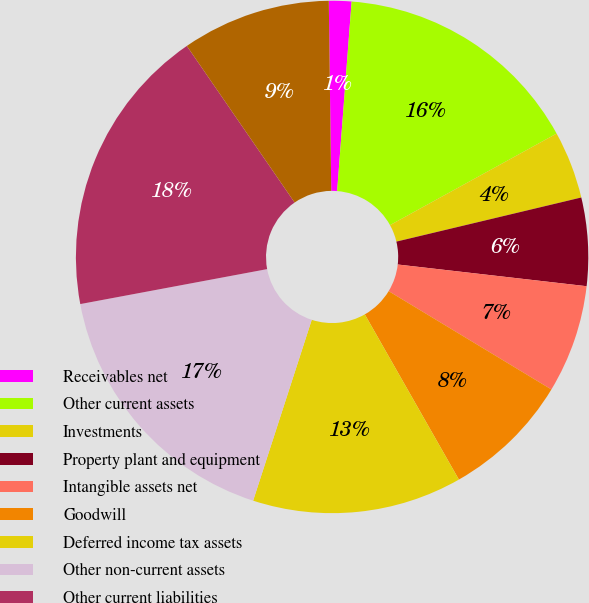<chart> <loc_0><loc_0><loc_500><loc_500><pie_chart><fcel>Receivables net<fcel>Other current assets<fcel>Investments<fcel>Property plant and equipment<fcel>Intangible assets net<fcel>Goodwill<fcel>Deferred income tax assets<fcel>Other non-current assets<fcel>Other current liabilities<fcel>Borrowings<nl><fcel>1.42%<fcel>15.79%<fcel>4.27%<fcel>5.55%<fcel>6.83%<fcel>8.11%<fcel>13.23%<fcel>17.07%<fcel>18.35%<fcel>9.39%<nl></chart> 